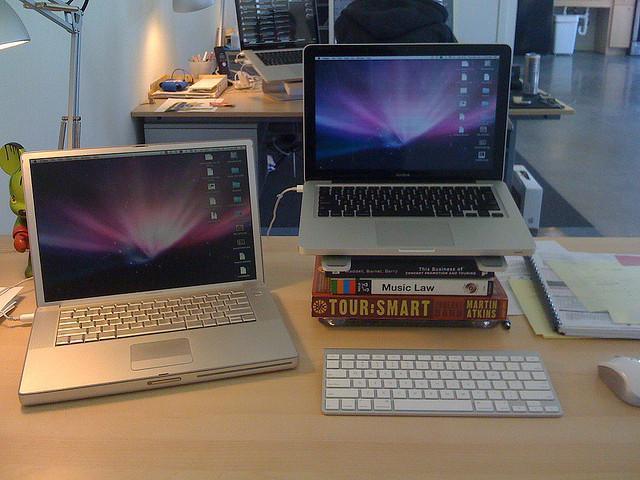How many keyboards can be seen?
Give a very brief answer. 3. How many closed laptops?
Give a very brief answer. 0. How many windows are open on both computers?
Give a very brief answer. 0. How many screens are on?
Give a very brief answer. 3. How many books are there?
Give a very brief answer. 3. How many laptops are visible?
Give a very brief answer. 3. How many people are behind the lady?
Give a very brief answer. 0. 